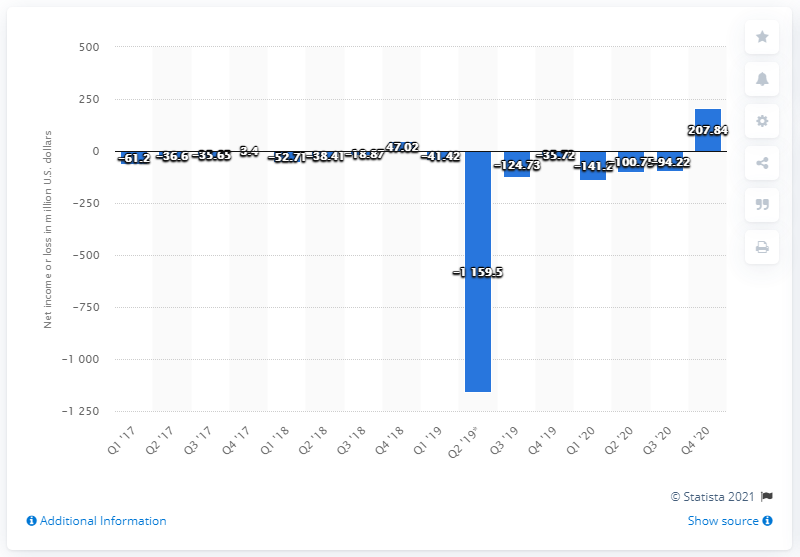Indicate a few pertinent items in this graphic. Pinterest's net income at the end of the fourth quarter of 2020 was 207.84 million dollars. 